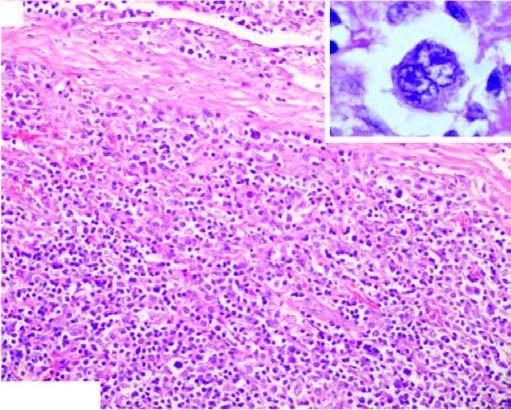re there bands of collagen forming nodules and characteristic lacunar rs cells?
Answer the question using a single word or phrase. Yes 